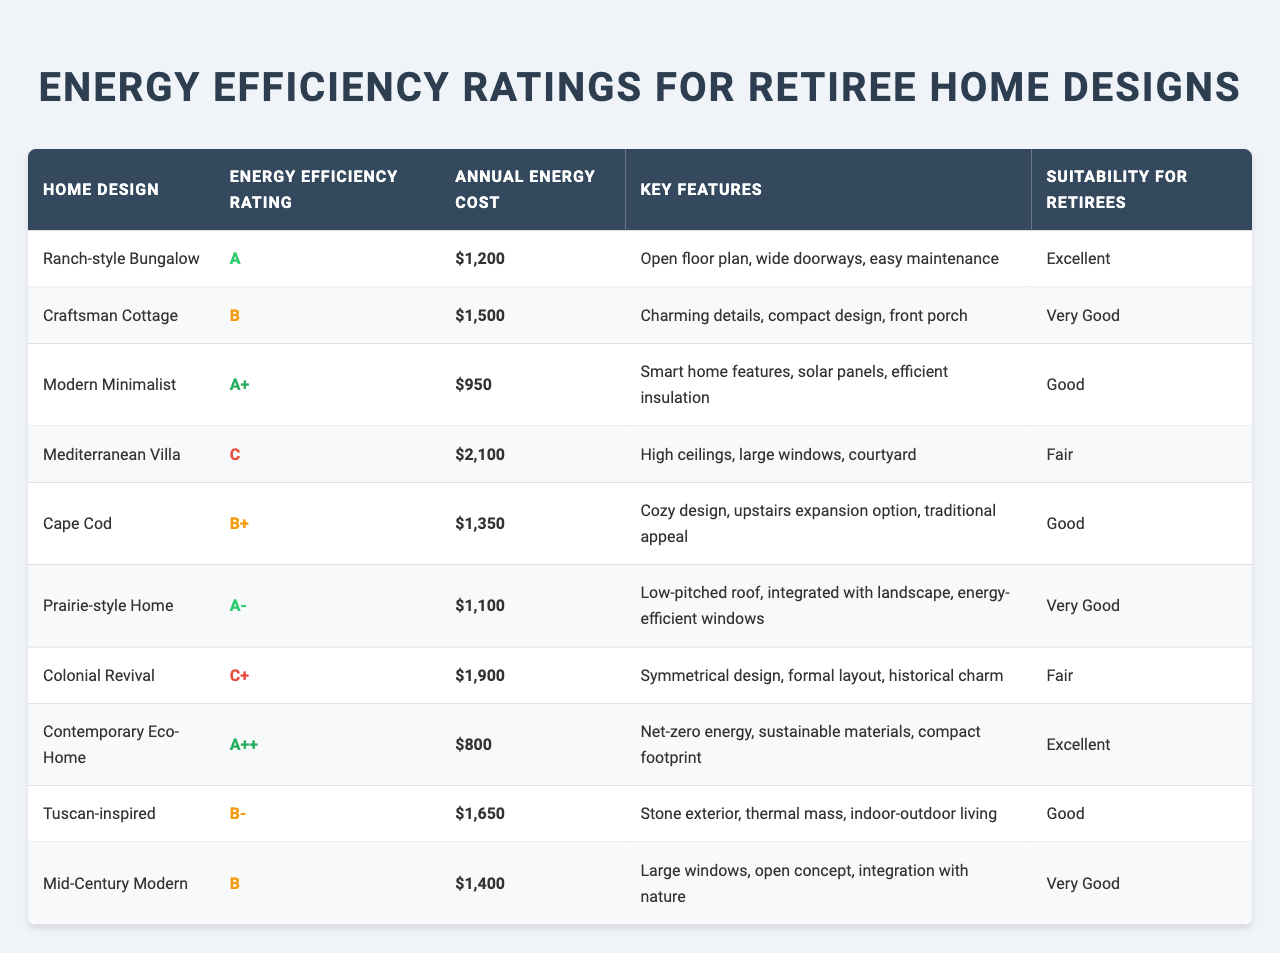What is the Energy Efficiency Rating of the Contemporary Eco-Home? The table shows that the Energy Efficiency Rating of the Contemporary Eco-Home is "A++".
Answer: A++ Which home design has the highest annual energy cost? By examining the "Annual Energy Cost" column, the Mediterranean Villa has the highest cost at $2,100.
Answer: $2,100 How many home designs have an Energy Efficiency Rating of 'B' or lower? In the table, there are four designs with a 'B' or lower rating: Craftsman Cottage (B), Mediterranean Villa (C), Colonial Revival (C+), and Tuscan-inspired (B-).
Answer: 4 What is the average annual energy cost of homes rated 'A'? The homes rated 'A' are the Ranch-style Bungalow ($1,200), Modern Minimalist ($950), Prairie-style Home ($1,100), and Contemporary Eco-Home ($800). The sum of these costs is $3,050, and there are 4 homes, so the average is $3,050 / 4 = $762.50.
Answer: $762.50 Is the Key Feature "Smart home features, solar panels, efficient insulation" associated with a home rated 'A'? Yes, this key feature belongs to the Modern Minimalist, which has an Energy Efficiency Rating of 'A'.
Answer: Yes Which home design is suitable for retirees and has the lowest annual energy cost? The Contemporary Eco-Home is rated 'Excellent' for suitability and has the lowest annual energy cost of $800.
Answer: Contemporary Eco-Home What Energy Efficiency Rating is assigned to homes that have "Cozy design" as a key feature? The Cape Cod is the only home with "Cozy design" as a key feature, and it has a rating of 'B+'.
Answer: B+ What is the total annual energy cost for all home designs rated 'B+' or higher? The homes with 'B+' or higher ratings are the Ranch-style Bungalow ($1,200), Modern Minimalist ($950), Prairie-style Home ($1,100), Cape Cod ($1,350), and Contemporary Eco-Home ($800). Summing these gives $1,200 + $950 + $1,100 + $1,350 + $800 = $5,400.
Answer: $5,400 Does any home design rated 'C' have features that might appeal to retirees? Yes, the Mediterranean Villa with its high ceilings and large windows may appeal to some retirees despite its 'C' rating.
Answer: Yes What percentage of the total home designs are categorized as "Good" suitability for retirees? There are 3 home designs rated as "Good": Modern Minimalist, Cape Cod, and Tuscan-inspired, from a total of 10 designs. Therefore, the percentage is (3/10)*100 = 30%.
Answer: 30% 